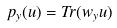Convert formula to latex. <formula><loc_0><loc_0><loc_500><loc_500>p _ { y } ( u ) = T r ( w _ { y } u )</formula> 